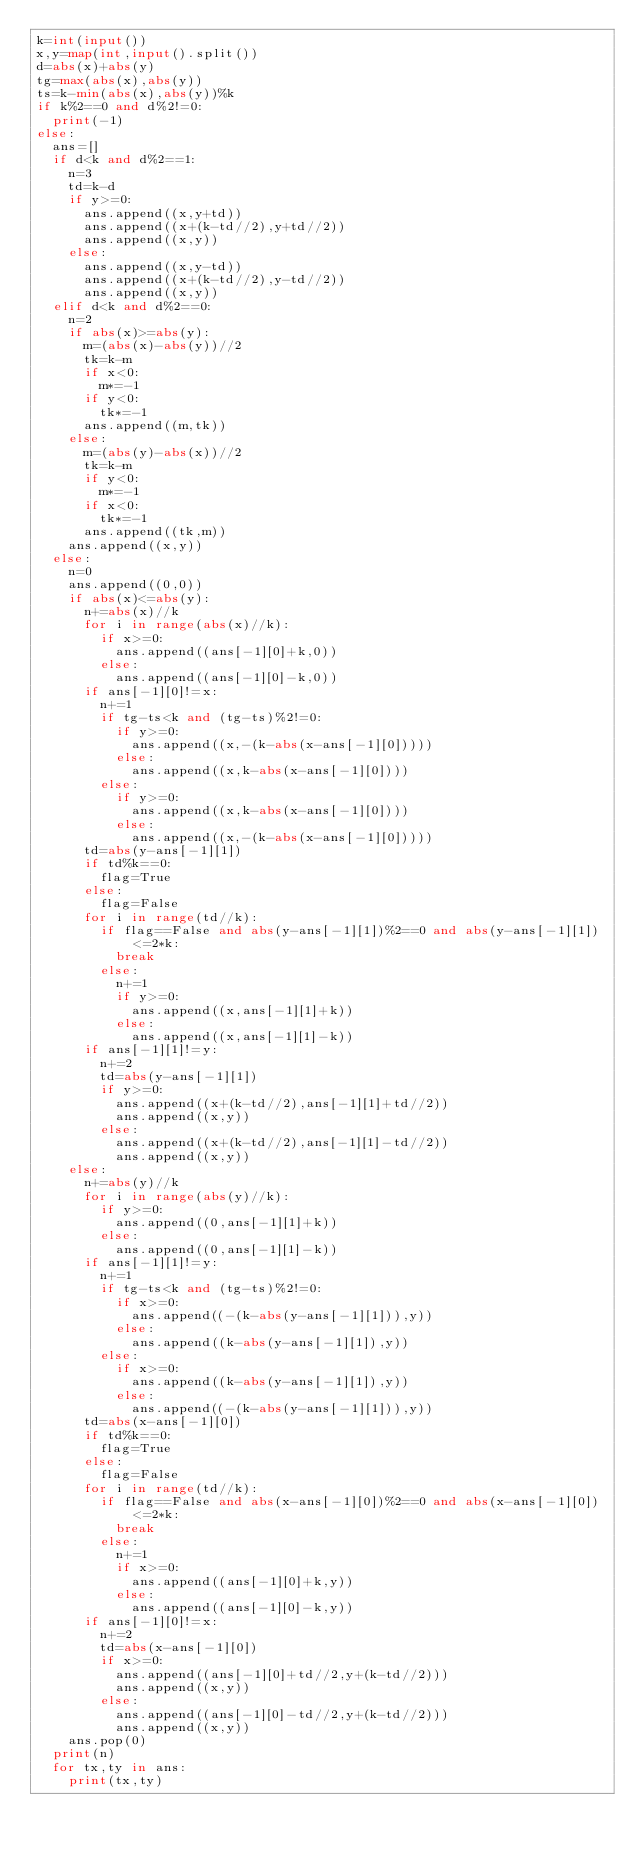Convert code to text. <code><loc_0><loc_0><loc_500><loc_500><_Python_>k=int(input())
x,y=map(int,input().split())
d=abs(x)+abs(y)
tg=max(abs(x),abs(y))
ts=k-min(abs(x),abs(y))%k
if k%2==0 and d%2!=0:
  print(-1)
else:
  ans=[]
  if d<k and d%2==1:
    n=3
    td=k-d
    if y>=0:
      ans.append((x,y+td))
      ans.append((x+(k-td//2),y+td//2))
      ans.append((x,y))
    else:
      ans.append((x,y-td))
      ans.append((x+(k-td//2),y-td//2))
      ans.append((x,y))
  elif d<k and d%2==0:
    n=2
    if abs(x)>=abs(y):
      m=(abs(x)-abs(y))//2
      tk=k-m
      if x<0:
        m*=-1
      if y<0:
        tk*=-1
      ans.append((m,tk))
    else:
      m=(abs(y)-abs(x))//2
      tk=k-m
      if y<0:
        m*=-1
      if x<0:
        tk*=-1
      ans.append((tk,m))
    ans.append((x,y))
  else:
    n=0
    ans.append((0,0))
    if abs(x)<=abs(y):
      n+=abs(x)//k
      for i in range(abs(x)//k):
        if x>=0:
          ans.append((ans[-1][0]+k,0))
        else:
          ans.append((ans[-1][0]-k,0))
      if ans[-1][0]!=x:
        n+=1
        if tg-ts<k and (tg-ts)%2!=0:
          if y>=0:
            ans.append((x,-(k-abs(x-ans[-1][0]))))
          else:
            ans.append((x,k-abs(x-ans[-1][0])))
        else:
          if y>=0:
            ans.append((x,k-abs(x-ans[-1][0])))
          else:
            ans.append((x,-(k-abs(x-ans[-1][0]))))
      td=abs(y-ans[-1][1])
      if td%k==0:
        flag=True
      else:
        flag=False
      for i in range(td//k):
        if flag==False and abs(y-ans[-1][1])%2==0 and abs(y-ans[-1][1])<=2*k:
          break
        else:
          n+=1
          if y>=0:
            ans.append((x,ans[-1][1]+k))
          else:
            ans.append((x,ans[-1][1]-k))
      if ans[-1][1]!=y:
        n+=2
        td=abs(y-ans[-1][1])
        if y>=0:
          ans.append((x+(k-td//2),ans[-1][1]+td//2))
          ans.append((x,y))
        else:
          ans.append((x+(k-td//2),ans[-1][1]-td//2))
          ans.append((x,y))
    else:
      n+=abs(y)//k
      for i in range(abs(y)//k):
        if y>=0:
          ans.append((0,ans[-1][1]+k))
        else:
          ans.append((0,ans[-1][1]-k))
      if ans[-1][1]!=y:
        n+=1
        if tg-ts<k and (tg-ts)%2!=0:
          if x>=0:
            ans.append((-(k-abs(y-ans[-1][1])),y))
          else:
            ans.append((k-abs(y-ans[-1][1]),y))
        else:
          if x>=0:
            ans.append((k-abs(y-ans[-1][1]),y))
          else:
            ans.append((-(k-abs(y-ans[-1][1])),y))
      td=abs(x-ans[-1][0])
      if td%k==0:
        flag=True
      else:
        flag=False
      for i in range(td//k):
        if flag==False and abs(x-ans[-1][0])%2==0 and abs(x-ans[-1][0])<=2*k:
          break
        else:
          n+=1
          if x>=0:
            ans.append((ans[-1][0]+k,y))
          else:
            ans.append((ans[-1][0]-k,y))
      if ans[-1][0]!=x:
        n+=2
        td=abs(x-ans[-1][0])
        if x>=0:
          ans.append((ans[-1][0]+td//2,y+(k-td//2)))
          ans.append((x,y))
        else:
          ans.append((ans[-1][0]-td//2,y+(k-td//2)))
          ans.append((x,y))
    ans.pop(0)
  print(n)
  for tx,ty in ans:
    print(tx,ty)</code> 